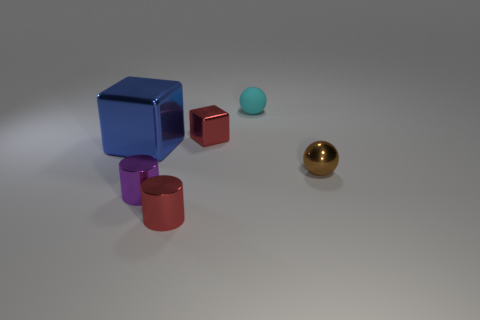Add 2 tiny cubes. How many objects exist? 8 Subtract all cylinders. How many objects are left? 4 Add 3 green rubber blocks. How many green rubber blocks exist? 3 Subtract 0 red balls. How many objects are left? 6 Subtract all small yellow rubber cubes. Subtract all tiny red objects. How many objects are left? 4 Add 3 blue blocks. How many blue blocks are left? 4 